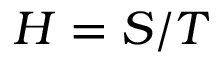<formula> <loc_0><loc_0><loc_500><loc_500>H = S / T</formula> 